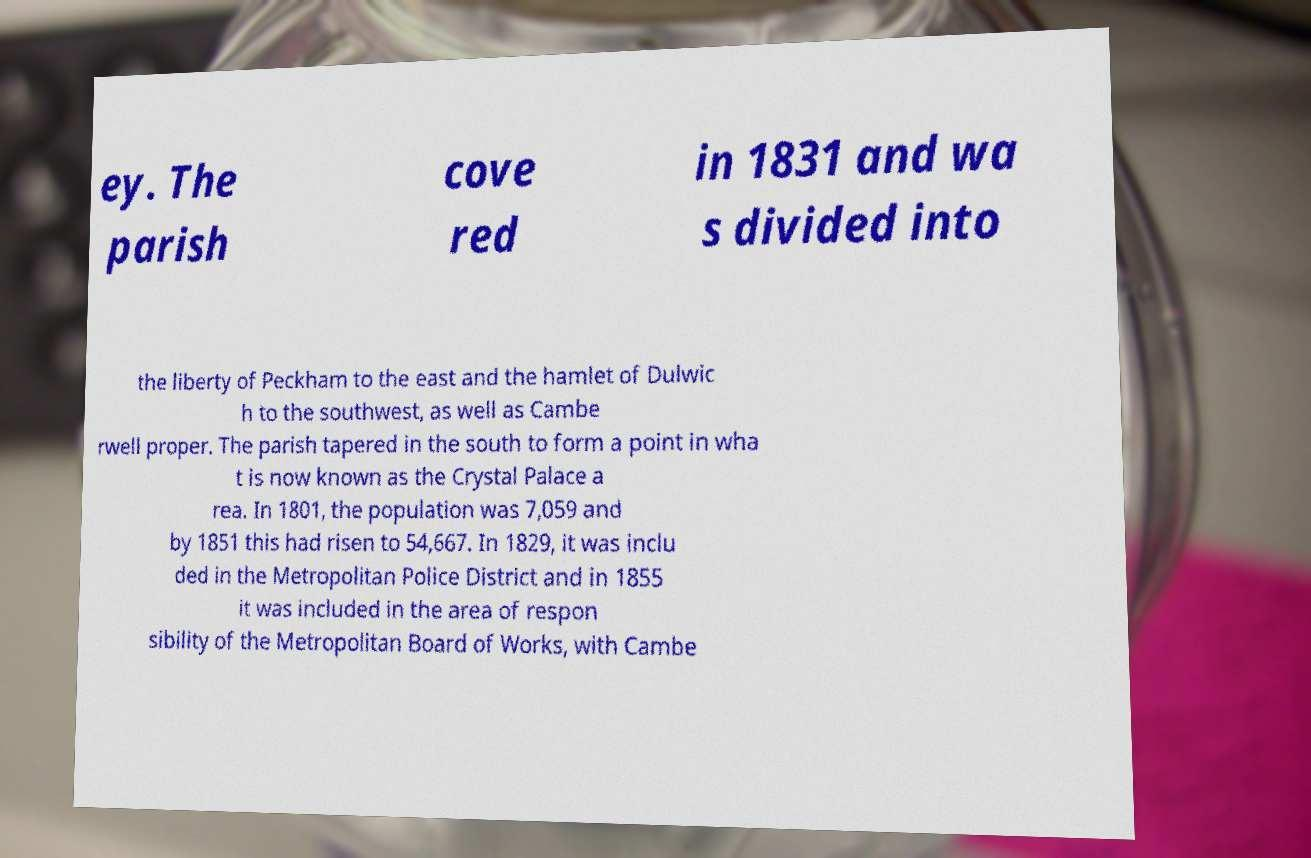Can you accurately transcribe the text from the provided image for me? ey. The parish cove red in 1831 and wa s divided into the liberty of Peckham to the east and the hamlet of Dulwic h to the southwest, as well as Cambe rwell proper. The parish tapered in the south to form a point in wha t is now known as the Crystal Palace a rea. In 1801, the population was 7,059 and by 1851 this had risen to 54,667. In 1829, it was inclu ded in the Metropolitan Police District and in 1855 it was included in the area of respon sibility of the Metropolitan Board of Works, with Cambe 